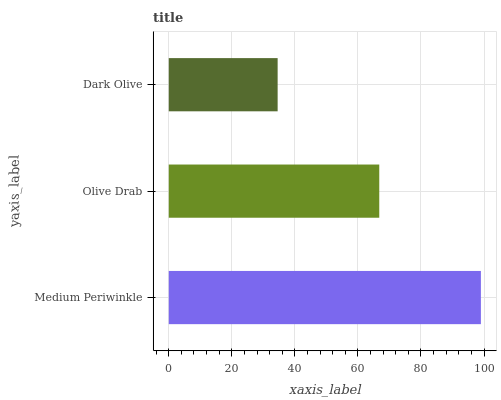Is Dark Olive the minimum?
Answer yes or no. Yes. Is Medium Periwinkle the maximum?
Answer yes or no. Yes. Is Olive Drab the minimum?
Answer yes or no. No. Is Olive Drab the maximum?
Answer yes or no. No. Is Medium Periwinkle greater than Olive Drab?
Answer yes or no. Yes. Is Olive Drab less than Medium Periwinkle?
Answer yes or no. Yes. Is Olive Drab greater than Medium Periwinkle?
Answer yes or no. No. Is Medium Periwinkle less than Olive Drab?
Answer yes or no. No. Is Olive Drab the high median?
Answer yes or no. Yes. Is Olive Drab the low median?
Answer yes or no. Yes. Is Medium Periwinkle the high median?
Answer yes or no. No. Is Medium Periwinkle the low median?
Answer yes or no. No. 